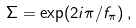<formula> <loc_0><loc_0><loc_500><loc_500>\Sigma = \exp ( 2 i \pi / f _ { \pi } ) \, ,</formula> 